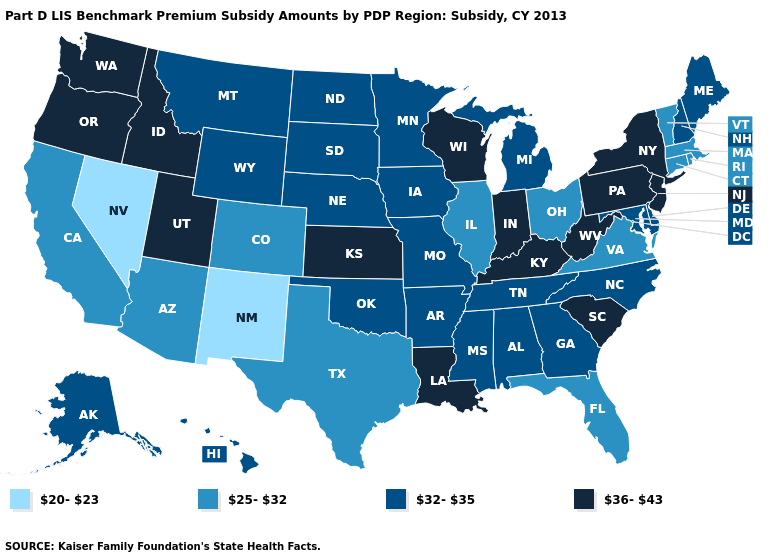Name the states that have a value in the range 20-23?
Short answer required. Nevada, New Mexico. Among the states that border Oklahoma , does New Mexico have the lowest value?
Write a very short answer. Yes. Does the map have missing data?
Concise answer only. No. Name the states that have a value in the range 25-32?
Short answer required. Arizona, California, Colorado, Connecticut, Florida, Illinois, Massachusetts, Ohio, Rhode Island, Texas, Vermont, Virginia. What is the highest value in states that border South Carolina?
Quick response, please. 32-35. Among the states that border Nevada , does Utah have the highest value?
Concise answer only. Yes. What is the value of Ohio?
Give a very brief answer. 25-32. Does South Carolina have the lowest value in the South?
Short answer required. No. What is the value of Colorado?
Short answer required. 25-32. What is the highest value in the West ?
Write a very short answer. 36-43. Name the states that have a value in the range 20-23?
Answer briefly. Nevada, New Mexico. Name the states that have a value in the range 25-32?
Give a very brief answer. Arizona, California, Colorado, Connecticut, Florida, Illinois, Massachusetts, Ohio, Rhode Island, Texas, Vermont, Virginia. What is the lowest value in the USA?
Concise answer only. 20-23. Among the states that border West Virginia , does Maryland have the lowest value?
Concise answer only. No. What is the highest value in the Northeast ?
Write a very short answer. 36-43. 